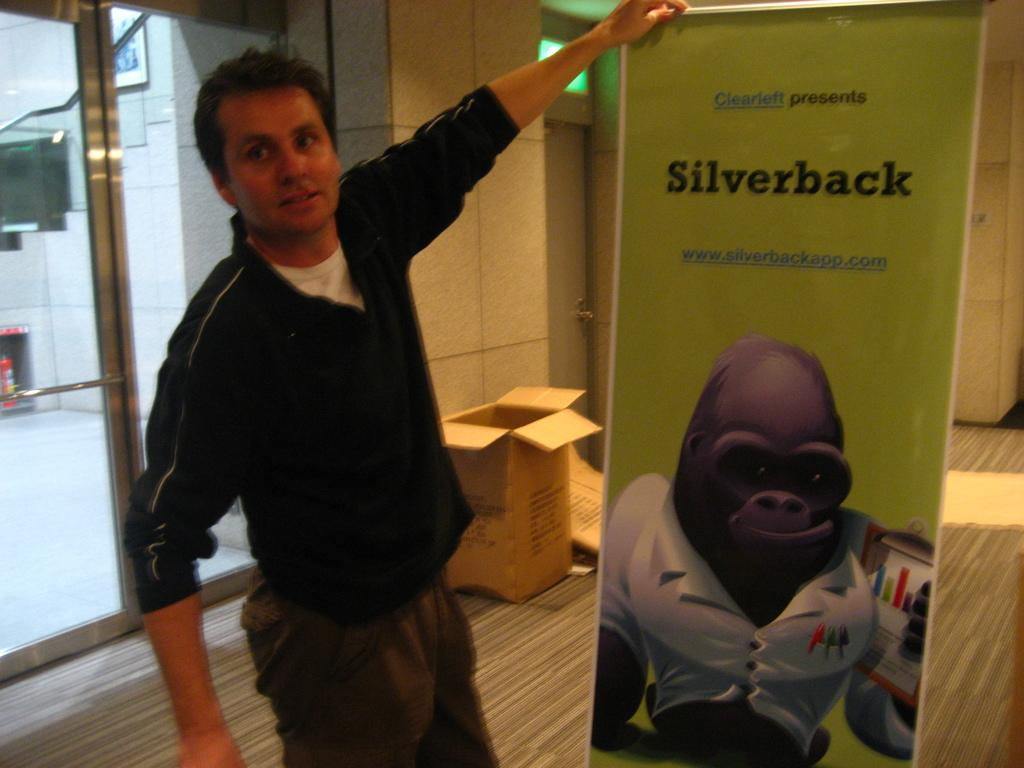What is the person in the image doing? The person is standing in the image and holding a banner. What is the person wearing in the image? The person is wearing a black t-shirt in the image. What can be seen in the background of the image? There is a carton in the background of the image. What architectural feature is visible on the left side of the image? There is a glass door on the left side of the image. What type of prose is being recited by the person in the image? There is no indication in the image that the person is reciting any prose. How does the rock contribute to the overall composition of the image? There is no rock present in the image. 